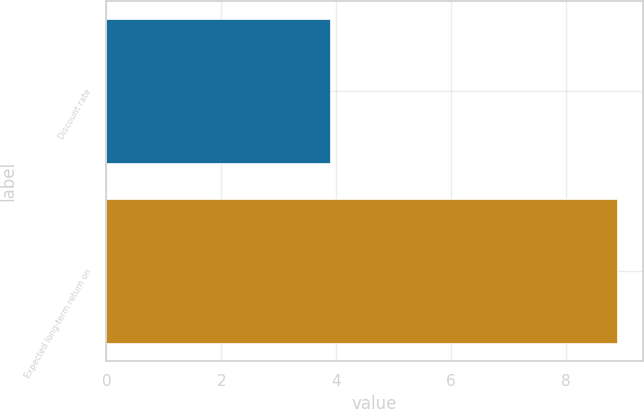Convert chart. <chart><loc_0><loc_0><loc_500><loc_500><bar_chart><fcel>Discount rate<fcel>Expected long-term return on<nl><fcel>3.9<fcel>8.9<nl></chart> 